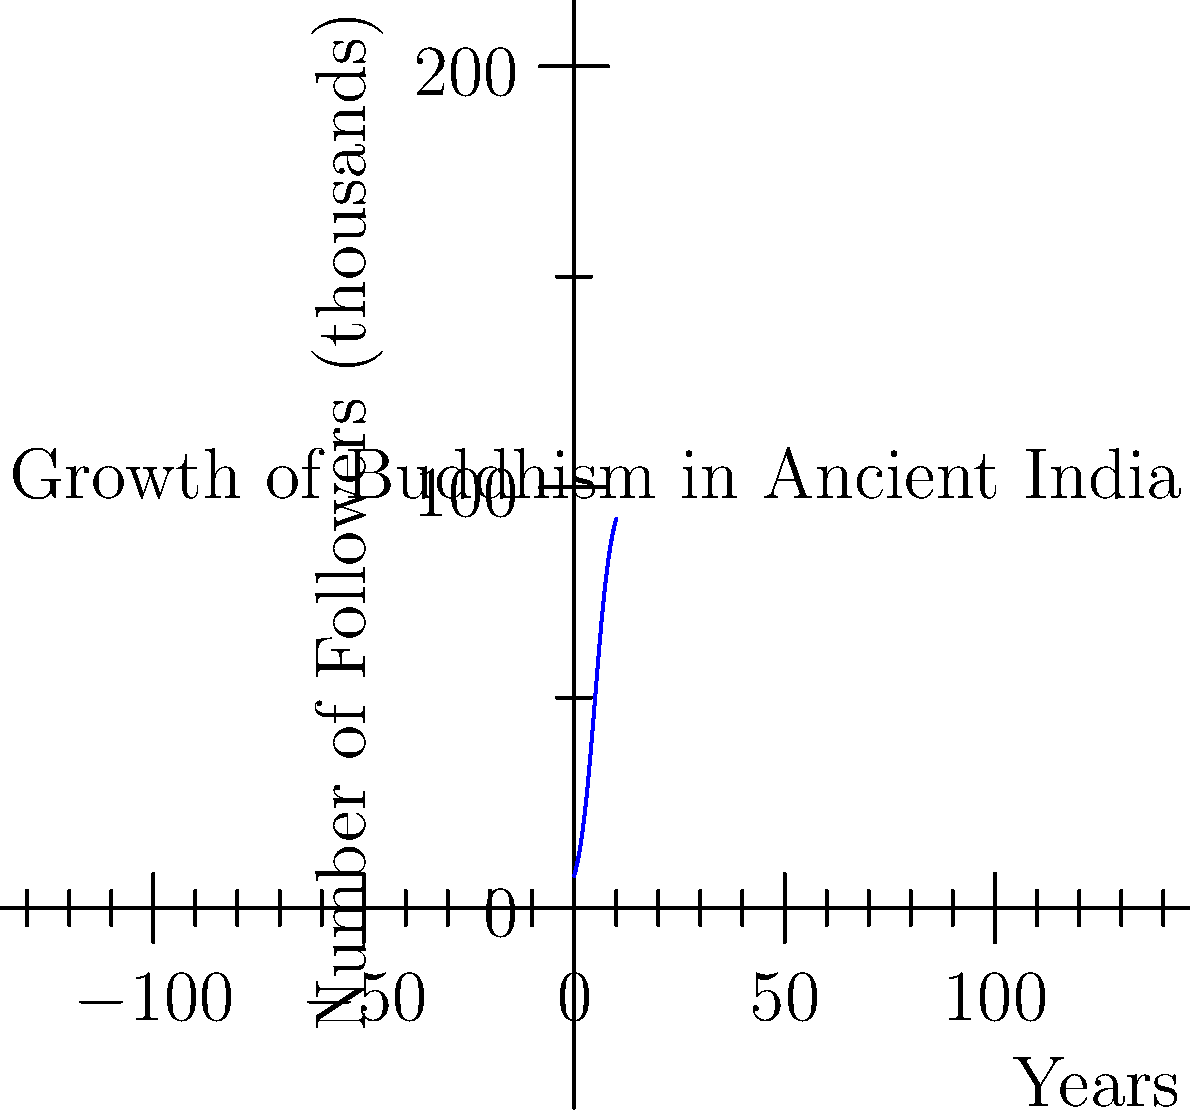The graph shows the growth of Buddhism in Ancient India over a 10-year period. If the spread of the faith follows a logistic growth model, what is the approximate number of followers (in thousands) at the 5-year mark? To answer this question, we need to analyze the logistic growth curve shown in the graph. Here's a step-by-step approach:

1. The logistic growth model is represented by an S-shaped curve, which we can see in the graph.

2. The midpoint of a logistic curve occurs at the inflection point, where the growth rate is highest.

3. In this graph, we can see that the inflection point appears to be around the 5-year mark on the x-axis.

4. At the inflection point of a logistic curve, the population size is typically half of the carrying capacity (the maximum population size).

5. Looking at the y-axis, we can see that the curve seems to level off around 100,000 followers.

6. Therefore, at the 5-year mark (the inflection point), we would expect the number of followers to be approximately half of 100,000.

7. Half of 100,000 is 50,000.

Thus, at the 5-year mark, the approximate number of followers would be 50,000.
Answer: 50,000 